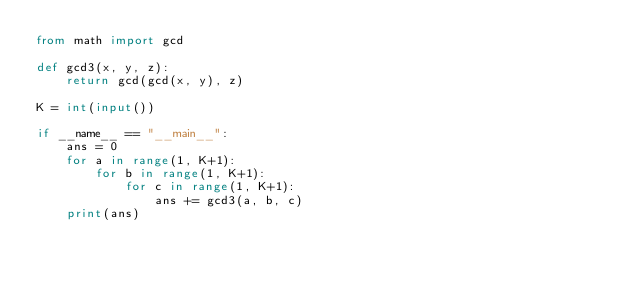Convert code to text. <code><loc_0><loc_0><loc_500><loc_500><_Python_>from math import gcd

def gcd3(x, y, z):
    return gcd(gcd(x, y), z)

K = int(input())

if __name__ == "__main__":
    ans = 0
    for a in range(1, K+1):
        for b in range(1, K+1):
            for c in range(1, K+1):
                ans += gcd3(a, b, c)
    print(ans)</code> 